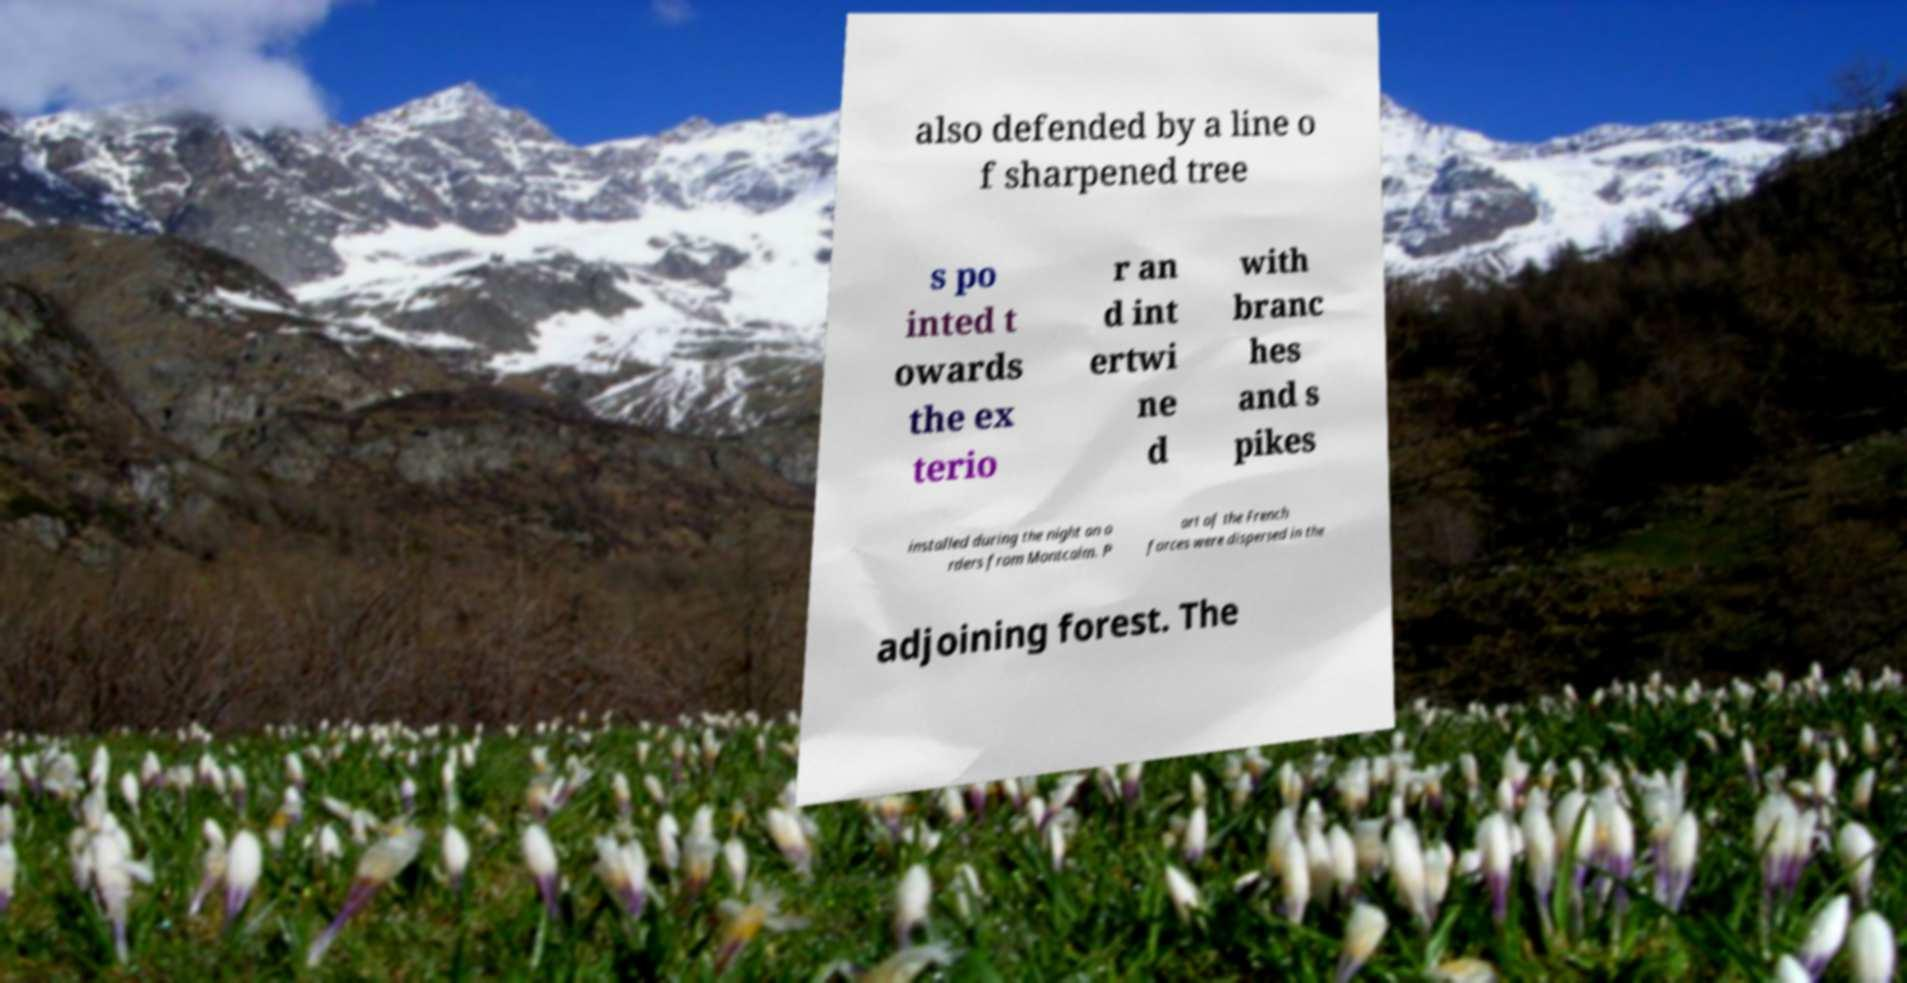Please read and relay the text visible in this image. What does it say? also defended by a line o f sharpened tree s po inted t owards the ex terio r an d int ertwi ne d with branc hes and s pikes installed during the night on o rders from Montcalm. P art of the French forces were dispersed in the adjoining forest. The 